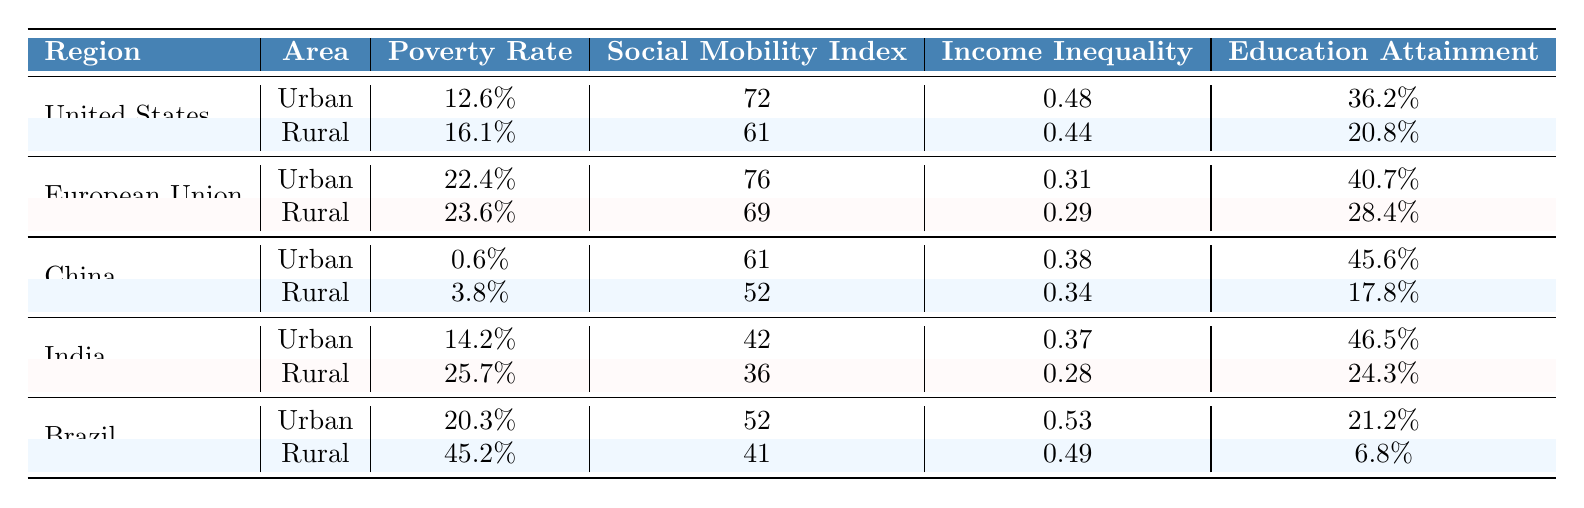What is the poverty rate in urban areas of the United States? The table shows that the poverty rate for urban areas in the United States is 12.6%.
Answer: 12.6% What is the Social Mobility Index for rural areas in the European Union? According to the table, the Social Mobility Index for rural areas in the European Union is 69.
Answer: 69 Which region has the highest poverty rate in urban areas? By examining the table, it's clear that the European Union has the highest urban poverty rate at 22.4%.
Answer: European Union What is the difference in poverty rates between rural and urban areas in India? The table states the rural poverty rate in India is 25.7% and the urban rate is 14.2%. So, the difference is 25.7% - 14.2% = 11.5%.
Answer: 11.5% Is the unemployment rate higher in rural or urban areas for Brazil? The table indicates that the unemployment rate in rural areas of Brazil is 8.1%, while it is 11.7% in urban areas.
Answer: Urban areas What is the average Social Mobility Index for urban areas across all regions? To find the average, I add the urban Social Mobility Indices: (72 + 76 + 61 + 42 + 52) = 303, then divide by 5 to get 303 / 5 = 60.6.
Answer: 60.6 Which region shows the largest gap between urban and rural education attainment? The education attainment for urban areas in Brazil is 21.2% and rural areas 6.8%, yielding a gap of 21.2% - 6.8% = 14.4%. Comparing this with other regions shows Brazil has the largest gap.
Answer: Brazil For which region is the Gini Index higher in urban areas compared to rural areas? In the table, the urban Gini Index for the United States (0.48) is higher than that of rural areas (0.44). No other region shows this pattern.
Answer: United States What is the combined rural poverty rate for China and Brazil? The rural poverty rates from the table show China at 3.8% and Brazil at 45.2%, so combined they are 3.8% + 45.2% = 49%.
Answer: 49% Is the income inequality higher in urban areas of India or China? The table lists India's urban income inequality at 0.37 and China's at 0.38, so China's is higher.
Answer: China 